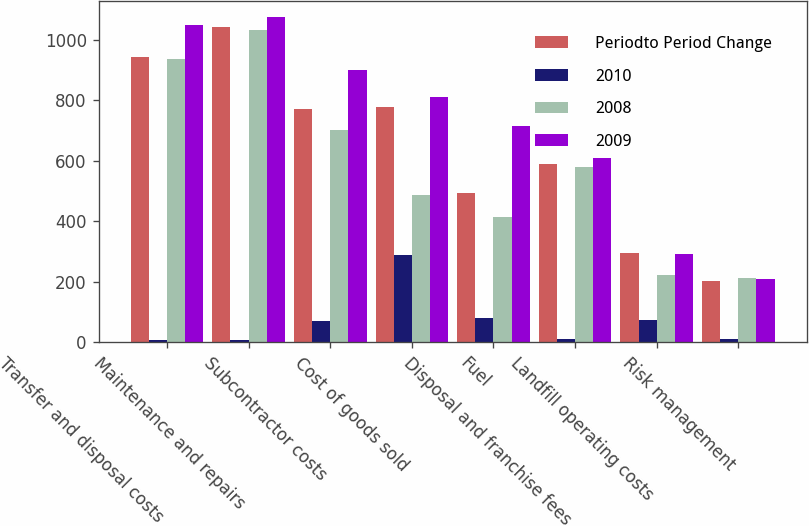Convert chart to OTSL. <chart><loc_0><loc_0><loc_500><loc_500><stacked_bar_chart><ecel><fcel>Transfer and disposal costs<fcel>Maintenance and repairs<fcel>Subcontractor costs<fcel>Cost of goods sold<fcel>Fuel<fcel>Disposal and franchise fees<fcel>Landfill operating costs<fcel>Risk management<nl><fcel>Periodto Period Change<fcel>943<fcel>1041<fcel>770<fcel>776<fcel>493<fcel>589<fcel>294<fcel>202<nl><fcel>2010<fcel>6<fcel>8<fcel>70<fcel>288<fcel>79<fcel>11<fcel>72<fcel>9<nl><fcel>2008<fcel>937<fcel>1033<fcel>700<fcel>488<fcel>414<fcel>578<fcel>222<fcel>211<nl><fcel>2009<fcel>1048<fcel>1074<fcel>901<fcel>812<fcel>715<fcel>608<fcel>291<fcel>209<nl></chart> 